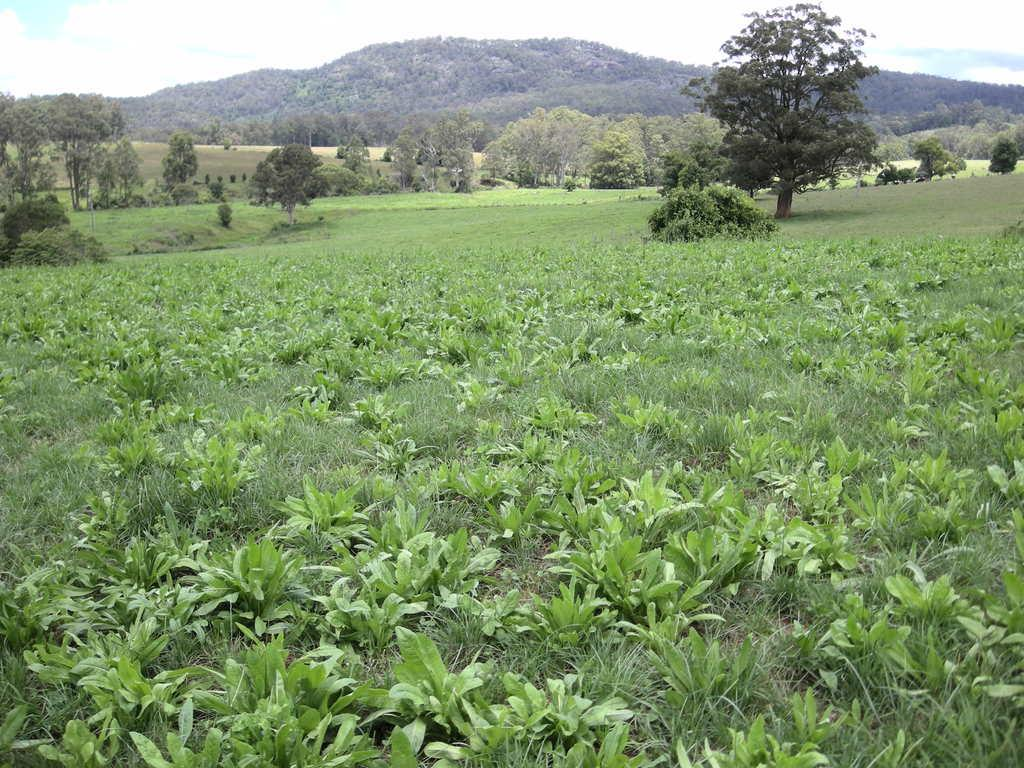What is located in the center of the image? There are trees, grass, and hills in the center of the image. What type of vegetation can be seen at the bottom of the image? There are plants at the bottom of the image. What is visible at the bottom of the image? The ground is visible at the bottom of the image. What can be seen in the sky at the top of the image? Clouds are present in the sky at the top of the image. How many maids are visible in the image? There are no maids present in the image. What type of animal can be seen grazing on the grass in the image? There are no animals visible in the image, such as bears or sheep. 